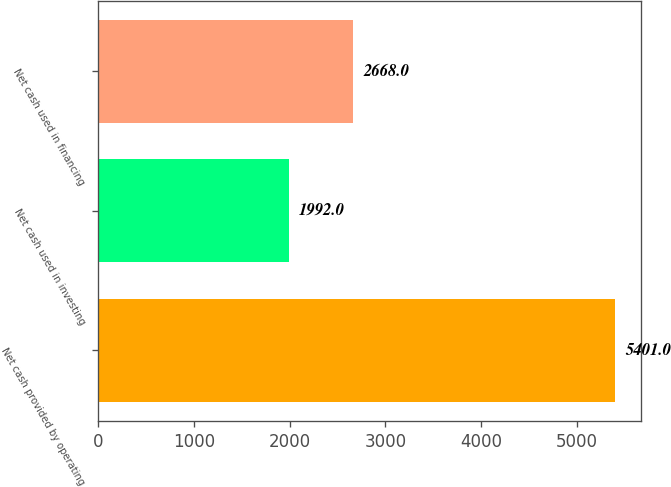Convert chart to OTSL. <chart><loc_0><loc_0><loc_500><loc_500><bar_chart><fcel>Net cash provided by operating<fcel>Net cash used in investing<fcel>Net cash used in financing<nl><fcel>5401<fcel>1992<fcel>2668<nl></chart> 